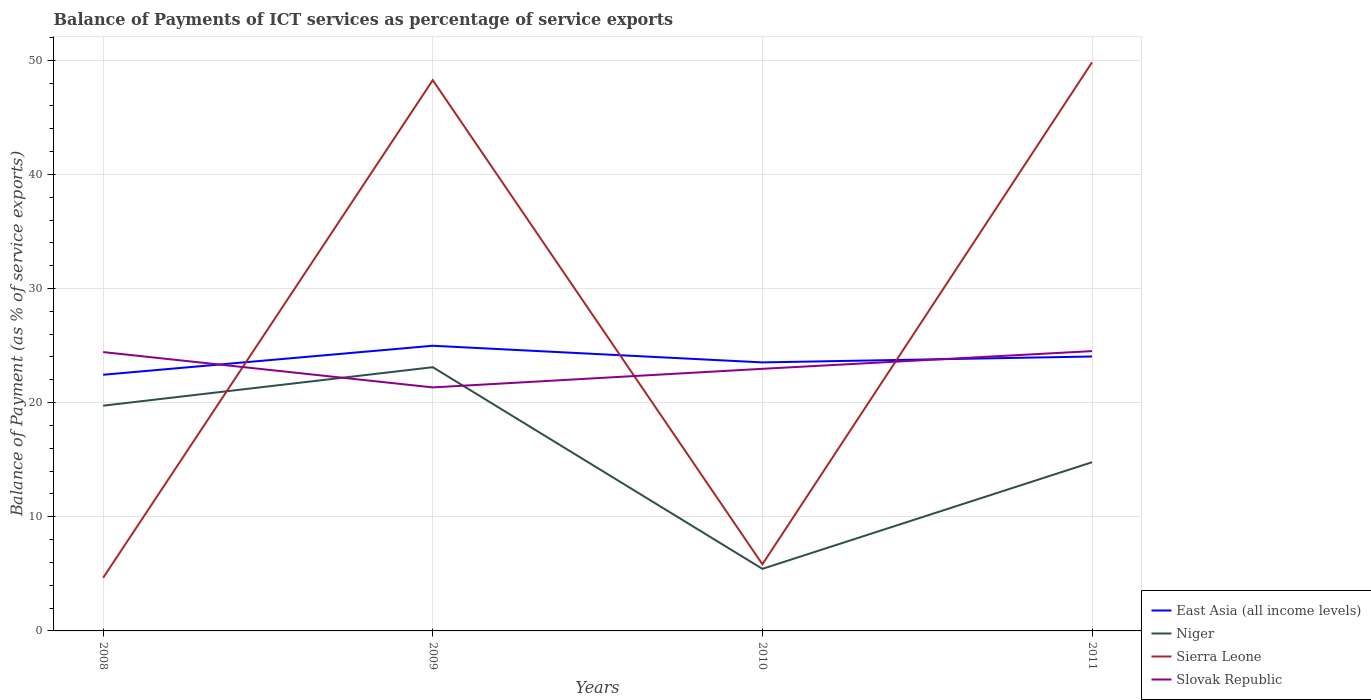Does the line corresponding to Sierra Leone intersect with the line corresponding to Slovak Republic?
Offer a very short reply. Yes. Is the number of lines equal to the number of legend labels?
Your response must be concise. Yes. Across all years, what is the maximum balance of payments of ICT services in Slovak Republic?
Provide a succinct answer. 21.33. In which year was the balance of payments of ICT services in Slovak Republic maximum?
Provide a short and direct response. 2009. What is the total balance of payments of ICT services in Slovak Republic in the graph?
Ensure brevity in your answer.  -1.55. What is the difference between the highest and the second highest balance of payments of ICT services in Slovak Republic?
Your answer should be very brief. 3.18. Is the balance of payments of ICT services in Niger strictly greater than the balance of payments of ICT services in Sierra Leone over the years?
Offer a terse response. No. How many years are there in the graph?
Keep it short and to the point. 4. Are the values on the major ticks of Y-axis written in scientific E-notation?
Provide a short and direct response. No. Does the graph contain grids?
Your answer should be compact. Yes. How are the legend labels stacked?
Give a very brief answer. Vertical. What is the title of the graph?
Provide a short and direct response. Balance of Payments of ICT services as percentage of service exports. What is the label or title of the X-axis?
Keep it short and to the point. Years. What is the label or title of the Y-axis?
Provide a short and direct response. Balance of Payment (as % of service exports). What is the Balance of Payment (as % of service exports) of East Asia (all income levels) in 2008?
Your response must be concise. 22.44. What is the Balance of Payment (as % of service exports) of Niger in 2008?
Provide a succinct answer. 19.73. What is the Balance of Payment (as % of service exports) of Sierra Leone in 2008?
Your answer should be very brief. 4.65. What is the Balance of Payment (as % of service exports) in Slovak Republic in 2008?
Your response must be concise. 24.43. What is the Balance of Payment (as % of service exports) of East Asia (all income levels) in 2009?
Ensure brevity in your answer.  24.98. What is the Balance of Payment (as % of service exports) of Niger in 2009?
Your answer should be very brief. 23.11. What is the Balance of Payment (as % of service exports) of Sierra Leone in 2009?
Offer a terse response. 48.26. What is the Balance of Payment (as % of service exports) of Slovak Republic in 2009?
Your answer should be very brief. 21.33. What is the Balance of Payment (as % of service exports) in East Asia (all income levels) in 2010?
Give a very brief answer. 23.53. What is the Balance of Payment (as % of service exports) of Niger in 2010?
Your response must be concise. 5.44. What is the Balance of Payment (as % of service exports) in Sierra Leone in 2010?
Provide a short and direct response. 5.84. What is the Balance of Payment (as % of service exports) of Slovak Republic in 2010?
Your response must be concise. 22.96. What is the Balance of Payment (as % of service exports) of East Asia (all income levels) in 2011?
Your response must be concise. 24.04. What is the Balance of Payment (as % of service exports) of Niger in 2011?
Keep it short and to the point. 14.78. What is the Balance of Payment (as % of service exports) in Sierra Leone in 2011?
Provide a short and direct response. 49.81. What is the Balance of Payment (as % of service exports) of Slovak Republic in 2011?
Provide a succinct answer. 24.51. Across all years, what is the maximum Balance of Payment (as % of service exports) in East Asia (all income levels)?
Ensure brevity in your answer.  24.98. Across all years, what is the maximum Balance of Payment (as % of service exports) in Niger?
Ensure brevity in your answer.  23.11. Across all years, what is the maximum Balance of Payment (as % of service exports) of Sierra Leone?
Your answer should be compact. 49.81. Across all years, what is the maximum Balance of Payment (as % of service exports) of Slovak Republic?
Make the answer very short. 24.51. Across all years, what is the minimum Balance of Payment (as % of service exports) of East Asia (all income levels)?
Offer a terse response. 22.44. Across all years, what is the minimum Balance of Payment (as % of service exports) in Niger?
Your answer should be compact. 5.44. Across all years, what is the minimum Balance of Payment (as % of service exports) of Sierra Leone?
Ensure brevity in your answer.  4.65. Across all years, what is the minimum Balance of Payment (as % of service exports) in Slovak Republic?
Your answer should be very brief. 21.33. What is the total Balance of Payment (as % of service exports) in East Asia (all income levels) in the graph?
Your answer should be compact. 95. What is the total Balance of Payment (as % of service exports) in Niger in the graph?
Make the answer very short. 63.06. What is the total Balance of Payment (as % of service exports) of Sierra Leone in the graph?
Your response must be concise. 108.56. What is the total Balance of Payment (as % of service exports) of Slovak Republic in the graph?
Offer a very short reply. 93.24. What is the difference between the Balance of Payment (as % of service exports) in East Asia (all income levels) in 2008 and that in 2009?
Offer a terse response. -2.54. What is the difference between the Balance of Payment (as % of service exports) in Niger in 2008 and that in 2009?
Offer a very short reply. -3.37. What is the difference between the Balance of Payment (as % of service exports) in Sierra Leone in 2008 and that in 2009?
Offer a very short reply. -43.6. What is the difference between the Balance of Payment (as % of service exports) in Slovak Republic in 2008 and that in 2009?
Offer a terse response. 3.09. What is the difference between the Balance of Payment (as % of service exports) of East Asia (all income levels) in 2008 and that in 2010?
Make the answer very short. -1.08. What is the difference between the Balance of Payment (as % of service exports) of Niger in 2008 and that in 2010?
Keep it short and to the point. 14.3. What is the difference between the Balance of Payment (as % of service exports) of Sierra Leone in 2008 and that in 2010?
Offer a very short reply. -1.18. What is the difference between the Balance of Payment (as % of service exports) in Slovak Republic in 2008 and that in 2010?
Provide a succinct answer. 1.47. What is the difference between the Balance of Payment (as % of service exports) of East Asia (all income levels) in 2008 and that in 2011?
Keep it short and to the point. -1.6. What is the difference between the Balance of Payment (as % of service exports) in Niger in 2008 and that in 2011?
Keep it short and to the point. 4.95. What is the difference between the Balance of Payment (as % of service exports) of Sierra Leone in 2008 and that in 2011?
Your answer should be compact. -45.16. What is the difference between the Balance of Payment (as % of service exports) in Slovak Republic in 2008 and that in 2011?
Provide a short and direct response. -0.09. What is the difference between the Balance of Payment (as % of service exports) of East Asia (all income levels) in 2009 and that in 2010?
Offer a terse response. 1.46. What is the difference between the Balance of Payment (as % of service exports) in Niger in 2009 and that in 2010?
Ensure brevity in your answer.  17.67. What is the difference between the Balance of Payment (as % of service exports) in Sierra Leone in 2009 and that in 2010?
Ensure brevity in your answer.  42.42. What is the difference between the Balance of Payment (as % of service exports) of Slovak Republic in 2009 and that in 2010?
Offer a very short reply. -1.63. What is the difference between the Balance of Payment (as % of service exports) of East Asia (all income levels) in 2009 and that in 2011?
Your response must be concise. 0.94. What is the difference between the Balance of Payment (as % of service exports) of Niger in 2009 and that in 2011?
Your answer should be compact. 8.33. What is the difference between the Balance of Payment (as % of service exports) of Sierra Leone in 2009 and that in 2011?
Provide a short and direct response. -1.56. What is the difference between the Balance of Payment (as % of service exports) in Slovak Republic in 2009 and that in 2011?
Ensure brevity in your answer.  -3.18. What is the difference between the Balance of Payment (as % of service exports) of East Asia (all income levels) in 2010 and that in 2011?
Give a very brief answer. -0.52. What is the difference between the Balance of Payment (as % of service exports) in Niger in 2010 and that in 2011?
Your response must be concise. -9.34. What is the difference between the Balance of Payment (as % of service exports) in Sierra Leone in 2010 and that in 2011?
Your response must be concise. -43.98. What is the difference between the Balance of Payment (as % of service exports) of Slovak Republic in 2010 and that in 2011?
Give a very brief answer. -1.55. What is the difference between the Balance of Payment (as % of service exports) of East Asia (all income levels) in 2008 and the Balance of Payment (as % of service exports) of Niger in 2009?
Make the answer very short. -0.66. What is the difference between the Balance of Payment (as % of service exports) of East Asia (all income levels) in 2008 and the Balance of Payment (as % of service exports) of Sierra Leone in 2009?
Your answer should be very brief. -25.81. What is the difference between the Balance of Payment (as % of service exports) in East Asia (all income levels) in 2008 and the Balance of Payment (as % of service exports) in Slovak Republic in 2009?
Keep it short and to the point. 1.11. What is the difference between the Balance of Payment (as % of service exports) of Niger in 2008 and the Balance of Payment (as % of service exports) of Sierra Leone in 2009?
Offer a terse response. -28.52. What is the difference between the Balance of Payment (as % of service exports) in Niger in 2008 and the Balance of Payment (as % of service exports) in Slovak Republic in 2009?
Your response must be concise. -1.6. What is the difference between the Balance of Payment (as % of service exports) in Sierra Leone in 2008 and the Balance of Payment (as % of service exports) in Slovak Republic in 2009?
Ensure brevity in your answer.  -16.68. What is the difference between the Balance of Payment (as % of service exports) in East Asia (all income levels) in 2008 and the Balance of Payment (as % of service exports) in Niger in 2010?
Provide a short and direct response. 17.01. What is the difference between the Balance of Payment (as % of service exports) of East Asia (all income levels) in 2008 and the Balance of Payment (as % of service exports) of Sierra Leone in 2010?
Give a very brief answer. 16.61. What is the difference between the Balance of Payment (as % of service exports) in East Asia (all income levels) in 2008 and the Balance of Payment (as % of service exports) in Slovak Republic in 2010?
Make the answer very short. -0.52. What is the difference between the Balance of Payment (as % of service exports) of Niger in 2008 and the Balance of Payment (as % of service exports) of Sierra Leone in 2010?
Provide a short and direct response. 13.9. What is the difference between the Balance of Payment (as % of service exports) of Niger in 2008 and the Balance of Payment (as % of service exports) of Slovak Republic in 2010?
Your answer should be compact. -3.23. What is the difference between the Balance of Payment (as % of service exports) in Sierra Leone in 2008 and the Balance of Payment (as % of service exports) in Slovak Republic in 2010?
Provide a succinct answer. -18.31. What is the difference between the Balance of Payment (as % of service exports) of East Asia (all income levels) in 2008 and the Balance of Payment (as % of service exports) of Niger in 2011?
Keep it short and to the point. 7.66. What is the difference between the Balance of Payment (as % of service exports) of East Asia (all income levels) in 2008 and the Balance of Payment (as % of service exports) of Sierra Leone in 2011?
Make the answer very short. -27.37. What is the difference between the Balance of Payment (as % of service exports) of East Asia (all income levels) in 2008 and the Balance of Payment (as % of service exports) of Slovak Republic in 2011?
Provide a short and direct response. -2.07. What is the difference between the Balance of Payment (as % of service exports) of Niger in 2008 and the Balance of Payment (as % of service exports) of Sierra Leone in 2011?
Make the answer very short. -30.08. What is the difference between the Balance of Payment (as % of service exports) of Niger in 2008 and the Balance of Payment (as % of service exports) of Slovak Republic in 2011?
Your answer should be very brief. -4.78. What is the difference between the Balance of Payment (as % of service exports) in Sierra Leone in 2008 and the Balance of Payment (as % of service exports) in Slovak Republic in 2011?
Give a very brief answer. -19.86. What is the difference between the Balance of Payment (as % of service exports) of East Asia (all income levels) in 2009 and the Balance of Payment (as % of service exports) of Niger in 2010?
Offer a very short reply. 19.55. What is the difference between the Balance of Payment (as % of service exports) in East Asia (all income levels) in 2009 and the Balance of Payment (as % of service exports) in Sierra Leone in 2010?
Give a very brief answer. 19.15. What is the difference between the Balance of Payment (as % of service exports) in East Asia (all income levels) in 2009 and the Balance of Payment (as % of service exports) in Slovak Republic in 2010?
Your answer should be very brief. 2.02. What is the difference between the Balance of Payment (as % of service exports) in Niger in 2009 and the Balance of Payment (as % of service exports) in Sierra Leone in 2010?
Your answer should be compact. 17.27. What is the difference between the Balance of Payment (as % of service exports) in Niger in 2009 and the Balance of Payment (as % of service exports) in Slovak Republic in 2010?
Your answer should be very brief. 0.14. What is the difference between the Balance of Payment (as % of service exports) in Sierra Leone in 2009 and the Balance of Payment (as % of service exports) in Slovak Republic in 2010?
Ensure brevity in your answer.  25.29. What is the difference between the Balance of Payment (as % of service exports) in East Asia (all income levels) in 2009 and the Balance of Payment (as % of service exports) in Niger in 2011?
Offer a very short reply. 10.21. What is the difference between the Balance of Payment (as % of service exports) of East Asia (all income levels) in 2009 and the Balance of Payment (as % of service exports) of Sierra Leone in 2011?
Your answer should be very brief. -24.83. What is the difference between the Balance of Payment (as % of service exports) in East Asia (all income levels) in 2009 and the Balance of Payment (as % of service exports) in Slovak Republic in 2011?
Keep it short and to the point. 0.47. What is the difference between the Balance of Payment (as % of service exports) of Niger in 2009 and the Balance of Payment (as % of service exports) of Sierra Leone in 2011?
Make the answer very short. -26.71. What is the difference between the Balance of Payment (as % of service exports) of Niger in 2009 and the Balance of Payment (as % of service exports) of Slovak Republic in 2011?
Provide a succinct answer. -1.41. What is the difference between the Balance of Payment (as % of service exports) in Sierra Leone in 2009 and the Balance of Payment (as % of service exports) in Slovak Republic in 2011?
Ensure brevity in your answer.  23.74. What is the difference between the Balance of Payment (as % of service exports) in East Asia (all income levels) in 2010 and the Balance of Payment (as % of service exports) in Niger in 2011?
Offer a very short reply. 8.75. What is the difference between the Balance of Payment (as % of service exports) of East Asia (all income levels) in 2010 and the Balance of Payment (as % of service exports) of Sierra Leone in 2011?
Give a very brief answer. -26.29. What is the difference between the Balance of Payment (as % of service exports) in East Asia (all income levels) in 2010 and the Balance of Payment (as % of service exports) in Slovak Republic in 2011?
Give a very brief answer. -0.99. What is the difference between the Balance of Payment (as % of service exports) of Niger in 2010 and the Balance of Payment (as % of service exports) of Sierra Leone in 2011?
Make the answer very short. -44.38. What is the difference between the Balance of Payment (as % of service exports) in Niger in 2010 and the Balance of Payment (as % of service exports) in Slovak Republic in 2011?
Keep it short and to the point. -19.08. What is the difference between the Balance of Payment (as % of service exports) in Sierra Leone in 2010 and the Balance of Payment (as % of service exports) in Slovak Republic in 2011?
Your answer should be very brief. -18.68. What is the average Balance of Payment (as % of service exports) of East Asia (all income levels) per year?
Provide a succinct answer. 23.75. What is the average Balance of Payment (as % of service exports) in Niger per year?
Your answer should be compact. 15.76. What is the average Balance of Payment (as % of service exports) of Sierra Leone per year?
Keep it short and to the point. 27.14. What is the average Balance of Payment (as % of service exports) of Slovak Republic per year?
Offer a terse response. 23.31. In the year 2008, what is the difference between the Balance of Payment (as % of service exports) of East Asia (all income levels) and Balance of Payment (as % of service exports) of Niger?
Give a very brief answer. 2.71. In the year 2008, what is the difference between the Balance of Payment (as % of service exports) in East Asia (all income levels) and Balance of Payment (as % of service exports) in Sierra Leone?
Provide a short and direct response. 17.79. In the year 2008, what is the difference between the Balance of Payment (as % of service exports) in East Asia (all income levels) and Balance of Payment (as % of service exports) in Slovak Republic?
Ensure brevity in your answer.  -1.99. In the year 2008, what is the difference between the Balance of Payment (as % of service exports) of Niger and Balance of Payment (as % of service exports) of Sierra Leone?
Offer a terse response. 15.08. In the year 2008, what is the difference between the Balance of Payment (as % of service exports) in Niger and Balance of Payment (as % of service exports) in Slovak Republic?
Give a very brief answer. -4.7. In the year 2008, what is the difference between the Balance of Payment (as % of service exports) of Sierra Leone and Balance of Payment (as % of service exports) of Slovak Republic?
Your response must be concise. -19.77. In the year 2009, what is the difference between the Balance of Payment (as % of service exports) of East Asia (all income levels) and Balance of Payment (as % of service exports) of Niger?
Give a very brief answer. 1.88. In the year 2009, what is the difference between the Balance of Payment (as % of service exports) of East Asia (all income levels) and Balance of Payment (as % of service exports) of Sierra Leone?
Keep it short and to the point. -23.27. In the year 2009, what is the difference between the Balance of Payment (as % of service exports) of East Asia (all income levels) and Balance of Payment (as % of service exports) of Slovak Republic?
Your answer should be compact. 3.65. In the year 2009, what is the difference between the Balance of Payment (as % of service exports) of Niger and Balance of Payment (as % of service exports) of Sierra Leone?
Your response must be concise. -25.15. In the year 2009, what is the difference between the Balance of Payment (as % of service exports) in Niger and Balance of Payment (as % of service exports) in Slovak Republic?
Your answer should be very brief. 1.77. In the year 2009, what is the difference between the Balance of Payment (as % of service exports) of Sierra Leone and Balance of Payment (as % of service exports) of Slovak Republic?
Provide a succinct answer. 26.92. In the year 2010, what is the difference between the Balance of Payment (as % of service exports) in East Asia (all income levels) and Balance of Payment (as % of service exports) in Niger?
Offer a terse response. 18.09. In the year 2010, what is the difference between the Balance of Payment (as % of service exports) of East Asia (all income levels) and Balance of Payment (as % of service exports) of Sierra Leone?
Provide a succinct answer. 17.69. In the year 2010, what is the difference between the Balance of Payment (as % of service exports) in East Asia (all income levels) and Balance of Payment (as % of service exports) in Slovak Republic?
Your answer should be compact. 0.56. In the year 2010, what is the difference between the Balance of Payment (as % of service exports) in Niger and Balance of Payment (as % of service exports) in Sierra Leone?
Give a very brief answer. -0.4. In the year 2010, what is the difference between the Balance of Payment (as % of service exports) in Niger and Balance of Payment (as % of service exports) in Slovak Republic?
Your response must be concise. -17.53. In the year 2010, what is the difference between the Balance of Payment (as % of service exports) in Sierra Leone and Balance of Payment (as % of service exports) in Slovak Republic?
Make the answer very short. -17.13. In the year 2011, what is the difference between the Balance of Payment (as % of service exports) in East Asia (all income levels) and Balance of Payment (as % of service exports) in Niger?
Ensure brevity in your answer.  9.26. In the year 2011, what is the difference between the Balance of Payment (as % of service exports) in East Asia (all income levels) and Balance of Payment (as % of service exports) in Sierra Leone?
Your answer should be very brief. -25.77. In the year 2011, what is the difference between the Balance of Payment (as % of service exports) of East Asia (all income levels) and Balance of Payment (as % of service exports) of Slovak Republic?
Your answer should be very brief. -0.47. In the year 2011, what is the difference between the Balance of Payment (as % of service exports) in Niger and Balance of Payment (as % of service exports) in Sierra Leone?
Give a very brief answer. -35.04. In the year 2011, what is the difference between the Balance of Payment (as % of service exports) in Niger and Balance of Payment (as % of service exports) in Slovak Republic?
Provide a succinct answer. -9.74. In the year 2011, what is the difference between the Balance of Payment (as % of service exports) in Sierra Leone and Balance of Payment (as % of service exports) in Slovak Republic?
Ensure brevity in your answer.  25.3. What is the ratio of the Balance of Payment (as % of service exports) in East Asia (all income levels) in 2008 to that in 2009?
Provide a short and direct response. 0.9. What is the ratio of the Balance of Payment (as % of service exports) of Niger in 2008 to that in 2009?
Your answer should be very brief. 0.85. What is the ratio of the Balance of Payment (as % of service exports) of Sierra Leone in 2008 to that in 2009?
Offer a very short reply. 0.1. What is the ratio of the Balance of Payment (as % of service exports) in Slovak Republic in 2008 to that in 2009?
Make the answer very short. 1.15. What is the ratio of the Balance of Payment (as % of service exports) in East Asia (all income levels) in 2008 to that in 2010?
Your answer should be compact. 0.95. What is the ratio of the Balance of Payment (as % of service exports) in Niger in 2008 to that in 2010?
Keep it short and to the point. 3.63. What is the ratio of the Balance of Payment (as % of service exports) of Sierra Leone in 2008 to that in 2010?
Provide a succinct answer. 0.8. What is the ratio of the Balance of Payment (as % of service exports) in Slovak Republic in 2008 to that in 2010?
Provide a short and direct response. 1.06. What is the ratio of the Balance of Payment (as % of service exports) of East Asia (all income levels) in 2008 to that in 2011?
Provide a short and direct response. 0.93. What is the ratio of the Balance of Payment (as % of service exports) in Niger in 2008 to that in 2011?
Ensure brevity in your answer.  1.34. What is the ratio of the Balance of Payment (as % of service exports) in Sierra Leone in 2008 to that in 2011?
Keep it short and to the point. 0.09. What is the ratio of the Balance of Payment (as % of service exports) of Slovak Republic in 2008 to that in 2011?
Keep it short and to the point. 1. What is the ratio of the Balance of Payment (as % of service exports) of East Asia (all income levels) in 2009 to that in 2010?
Your answer should be compact. 1.06. What is the ratio of the Balance of Payment (as % of service exports) in Niger in 2009 to that in 2010?
Provide a succinct answer. 4.25. What is the ratio of the Balance of Payment (as % of service exports) of Sierra Leone in 2009 to that in 2010?
Offer a terse response. 8.27. What is the ratio of the Balance of Payment (as % of service exports) in Slovak Republic in 2009 to that in 2010?
Provide a succinct answer. 0.93. What is the ratio of the Balance of Payment (as % of service exports) in East Asia (all income levels) in 2009 to that in 2011?
Offer a terse response. 1.04. What is the ratio of the Balance of Payment (as % of service exports) of Niger in 2009 to that in 2011?
Your answer should be compact. 1.56. What is the ratio of the Balance of Payment (as % of service exports) of Sierra Leone in 2009 to that in 2011?
Provide a succinct answer. 0.97. What is the ratio of the Balance of Payment (as % of service exports) of Slovak Republic in 2009 to that in 2011?
Offer a very short reply. 0.87. What is the ratio of the Balance of Payment (as % of service exports) in East Asia (all income levels) in 2010 to that in 2011?
Provide a short and direct response. 0.98. What is the ratio of the Balance of Payment (as % of service exports) of Niger in 2010 to that in 2011?
Offer a terse response. 0.37. What is the ratio of the Balance of Payment (as % of service exports) of Sierra Leone in 2010 to that in 2011?
Make the answer very short. 0.12. What is the ratio of the Balance of Payment (as % of service exports) in Slovak Republic in 2010 to that in 2011?
Offer a terse response. 0.94. What is the difference between the highest and the second highest Balance of Payment (as % of service exports) in East Asia (all income levels)?
Your response must be concise. 0.94. What is the difference between the highest and the second highest Balance of Payment (as % of service exports) of Niger?
Keep it short and to the point. 3.37. What is the difference between the highest and the second highest Balance of Payment (as % of service exports) in Sierra Leone?
Ensure brevity in your answer.  1.56. What is the difference between the highest and the second highest Balance of Payment (as % of service exports) in Slovak Republic?
Provide a succinct answer. 0.09. What is the difference between the highest and the lowest Balance of Payment (as % of service exports) of East Asia (all income levels)?
Offer a very short reply. 2.54. What is the difference between the highest and the lowest Balance of Payment (as % of service exports) in Niger?
Ensure brevity in your answer.  17.67. What is the difference between the highest and the lowest Balance of Payment (as % of service exports) in Sierra Leone?
Your answer should be compact. 45.16. What is the difference between the highest and the lowest Balance of Payment (as % of service exports) in Slovak Republic?
Give a very brief answer. 3.18. 